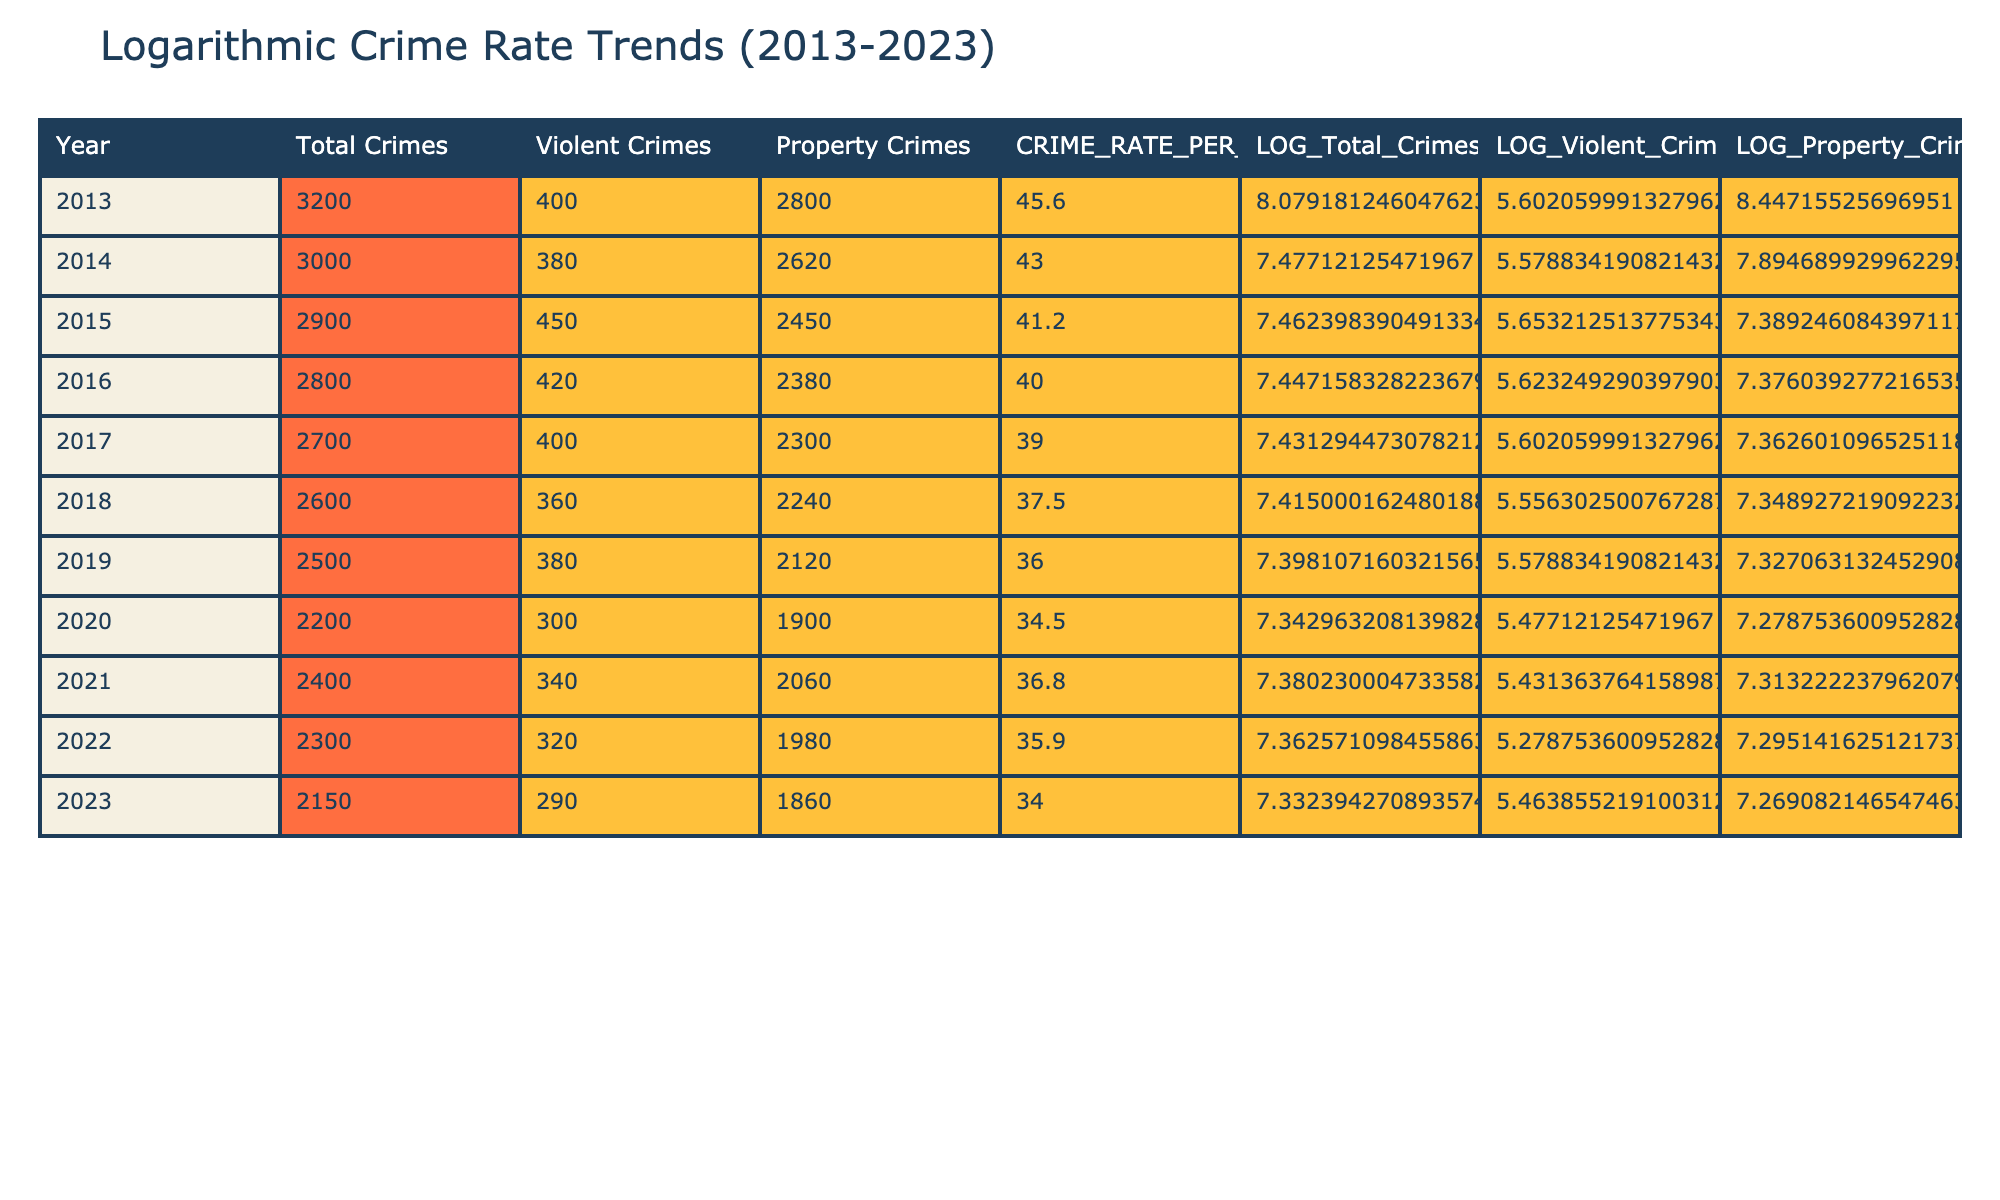What year had the highest total crimes recorded? By examining the "Total Crimes" column, the highest value is 3200 in the year 2013.
Answer: 2013 What is the total number of violent crimes reported in 2020? The "Violent Crimes" column shows that there were 300 violent crimes reported in 2020.
Answer: 300 What is the average crime rate per 1000 over the decade? To find the average crime rate, add all the values in the "CRIME_RATE_PER_1000" column (45.6 + 43.0 + 41.2 + 40.0 + 39.0 + 37.5 + 36.0 + 34.5 + 36.8 + 35.9 + 34.0 =  415.5), and then divide by 11 (the number of years): 415.5 / 11 = 37.86.
Answer: 37.86 Did the total number of property crimes increase from 2013 to 2023? In 2013, the number of property crimes was 2800, and in 2023 it was 1860. Since 1860 is less than 2800, the total number of property crimes did not increase.
Answer: No What was the percentage decrease in total crimes from 2013 to 2023? The total crimes decreased from 3200 in 2013 to 2150 in 2023. The decrease is 3200 - 2150 = 1050. To find the percentage decrease, use the formula (decrease/original number) * 100 = (1050/3200) * 100 = 32.81%.
Answer: 32.81% Which year experienced the least number of violent crimes? By checking the "Violent Crimes" column, the lowest value is 290 in 2023.
Answer: 290 How do the total crimes in 2022 compare to those in 2019? In 2022, the total crimes were 2300, while in 2019, they were 2500. The comparison shows that total crimes decreased by 250 from 2019 to 2022.
Answer: Decreased by 250 Which years had an increase in total crimes compared to the previous year? Reviewing the "Total Crimes" column shows that there is an increase only from 2020 (2200) to 2021 (2400).
Answer: 2021 What was the largest decrease in property crimes from one year to the next during the decade? Examining the "Property Crimes" column, the largest decrease was from 2021 (2060) to 2022 (1980), which is a decrease of 80 crimes.
Answer: 80 